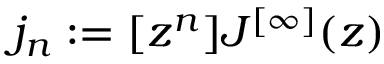Convert formula to latex. <formula><loc_0><loc_0><loc_500><loc_500>j _ { n } \colon = [ z ^ { n } ] J ^ { [ \infty ] } ( z )</formula> 